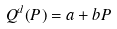<formula> <loc_0><loc_0><loc_500><loc_500>Q ^ { d } ( P ) = a + b P</formula> 